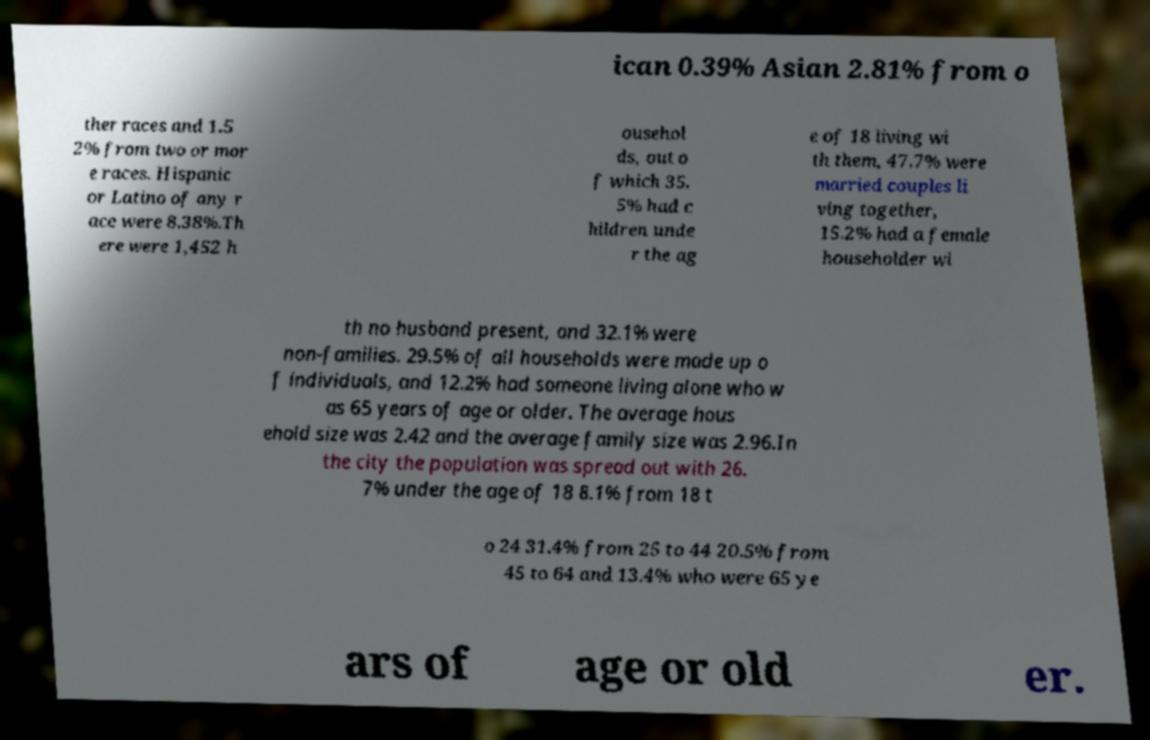Can you accurately transcribe the text from the provided image for me? ican 0.39% Asian 2.81% from o ther races and 1.5 2% from two or mor e races. Hispanic or Latino of any r ace were 8.38%.Th ere were 1,452 h ousehol ds, out o f which 35. 5% had c hildren unde r the ag e of 18 living wi th them, 47.7% were married couples li ving together, 15.2% had a female householder wi th no husband present, and 32.1% were non-families. 29.5% of all households were made up o f individuals, and 12.2% had someone living alone who w as 65 years of age or older. The average hous ehold size was 2.42 and the average family size was 2.96.In the city the population was spread out with 26. 7% under the age of 18 8.1% from 18 t o 24 31.4% from 25 to 44 20.5% from 45 to 64 and 13.4% who were 65 ye ars of age or old er. 